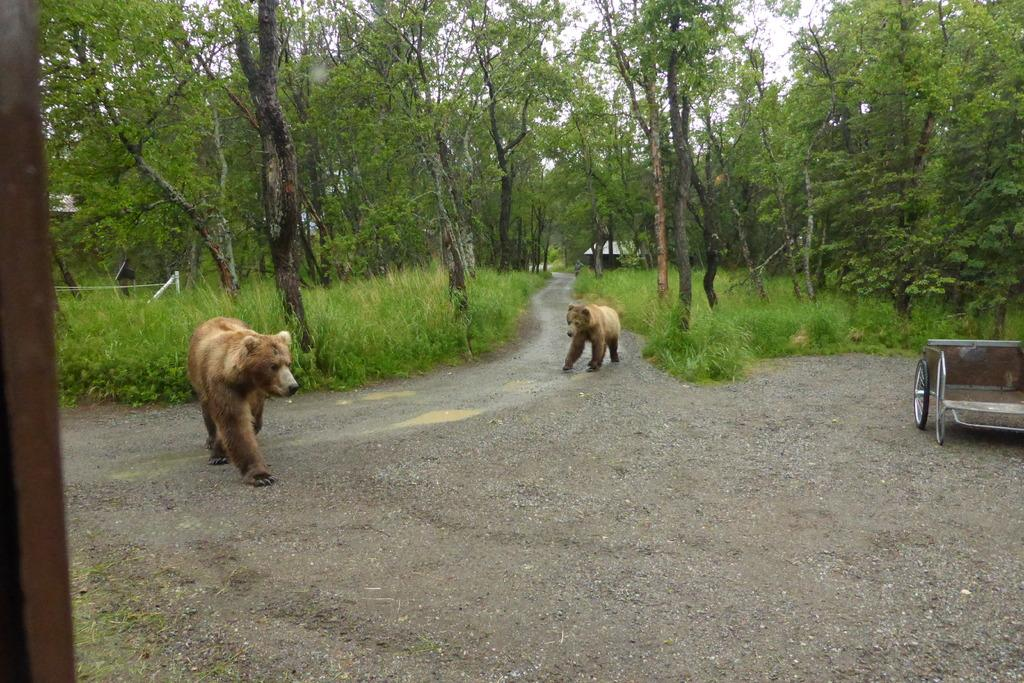What is happening in the center of the image? There are animals walking in the center of the image. What can be seen on the right side of the image? There is a vehicle on the right side of the image. What type of vegetation is visible in the background of the image? There is grass on the ground in the background of the image. What else can be seen in the background of the image? There are trees in the background of the image. How many cakes are being shared by the brothers in the image? There are no cakes or brothers present in the image. What type of mine is visible in the image? There is no mine present in the image. 